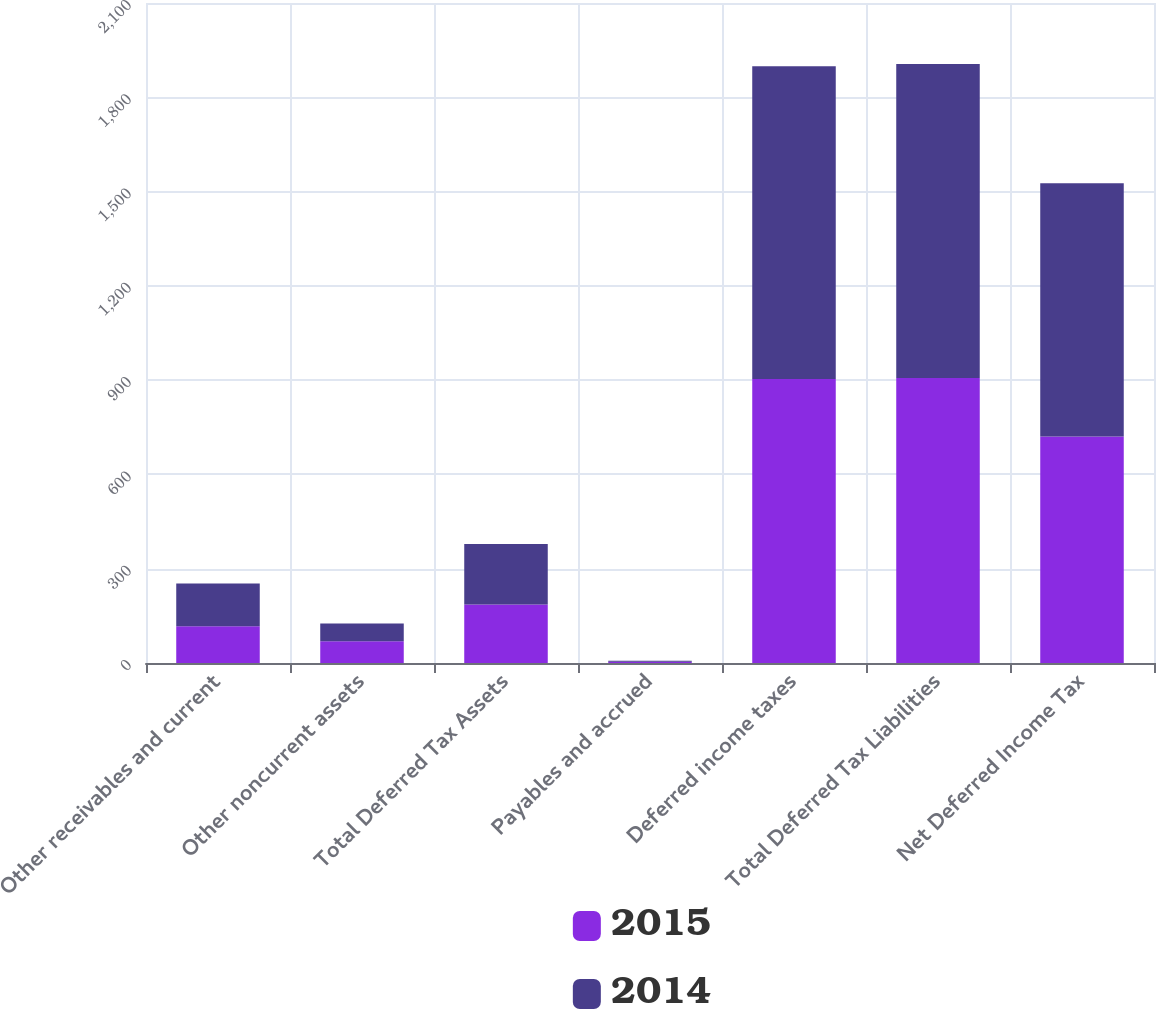<chart> <loc_0><loc_0><loc_500><loc_500><stacked_bar_chart><ecel><fcel>Other receivables and current<fcel>Other noncurrent assets<fcel>Total Deferred Tax Assets<fcel>Payables and accrued<fcel>Deferred income taxes<fcel>Total Deferred Tax Liabilities<fcel>Net Deferred Income Tax<nl><fcel>2015<fcel>117.2<fcel>69<fcel>186.2<fcel>3.6<fcel>903.3<fcel>906.9<fcel>720.7<nl><fcel>2014<fcel>136<fcel>56.6<fcel>192.6<fcel>3.2<fcel>995.5<fcel>998.7<fcel>806.1<nl></chart> 